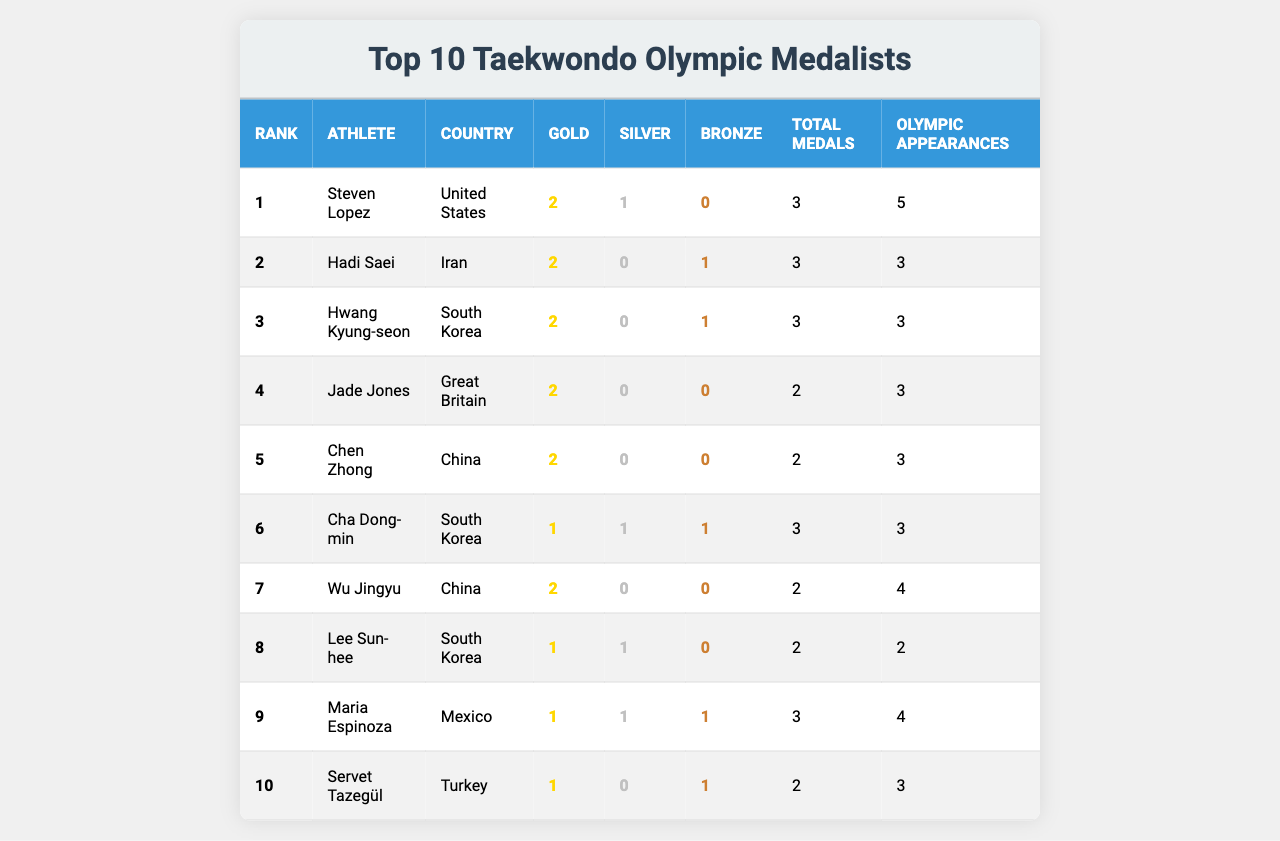What is the highest number of gold medals won by an athlete? Steven Lopez, Hadi Saei, Hwang Kyung-seon, Jade Jones, Chen Zhong, and Wu Jingyu all have 2 gold medals, which is the maximum value in the Gold column.
Answer: 2 How many total medals did Maria Espinoza win? By referring to the Total Medals column, Maria Espinoza is listed with 3 total medals.
Answer: 3 Which athlete has the most Olympic appearances? The athlete with the highest number of Olympic appearances is Steven Lopez, who has appeared in 5 Olympics, as indicated in the Olympic Appearances column.
Answer: 5 How many more gold medals does Jade Jones have compared to Lee Sun-hee? Jade Jones has 2 gold medals, while Lee Sun-hee has 1. The difference is 2 - 1 = 1 gold medal.
Answer: 1 Is it true that the top-ranked athlete won only gold medals? No, the top-ranked athlete, Steven Lopez, won 2 gold medals but also won a silver medal; therefore, not all of his medals are gold.
Answer: No What is the average number of total medals won by the athletes? The total number of medals can be summed as 3 + 3 + 3 + 2 + 2 + 3 + 2 + 2 + 3 + 2 = 25. Since there are 10 athletes, the average is 25 / 10 = 2.5.
Answer: 2.5 Which country appears most frequently in the top 10 list? Both South Korea and the United States have 3 appearances each in the list, while other countries appear less frequently, making them the countries with the most entries.
Answer: South Korea and United States How many total medals have been won by athletes from China? Athletes from China are Chen Zhong and Wu Jingyu, who have a total of 2 and 2 medals respectively. Adding these gives 2 + 2 = 4 total medals.
Answer: 4 Who is the only athlete to have won all three types of medals? Cha Dong-min is the only athlete who won 1 gold, 1 silver, and 1 bronze, making him the only one with all three types of medals according to the medals won by athletes.
Answer: Cha Dong-min What is the difference in total medals between the athlete with the most and the athlete with the least? The athlete with the most medals, Steven Lopez, has 3 total medals while the athlete with the least, Servet Tazegül, has 2. The difference is 3 - 2 = 1 total medal.
Answer: 1 